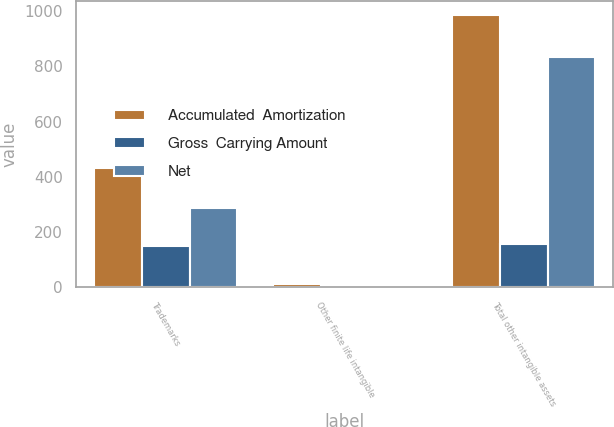<chart> <loc_0><loc_0><loc_500><loc_500><stacked_bar_chart><ecel><fcel>Trademarks<fcel>Other finite life intangible<fcel>Total other intangible assets<nl><fcel>Accumulated  Amortization<fcel>432.1<fcel>10.2<fcel>987.8<nl><fcel>Gross  Carrying Amount<fcel>147<fcel>8.4<fcel>155.4<nl><fcel>Net<fcel>285.1<fcel>1.8<fcel>832.4<nl></chart> 